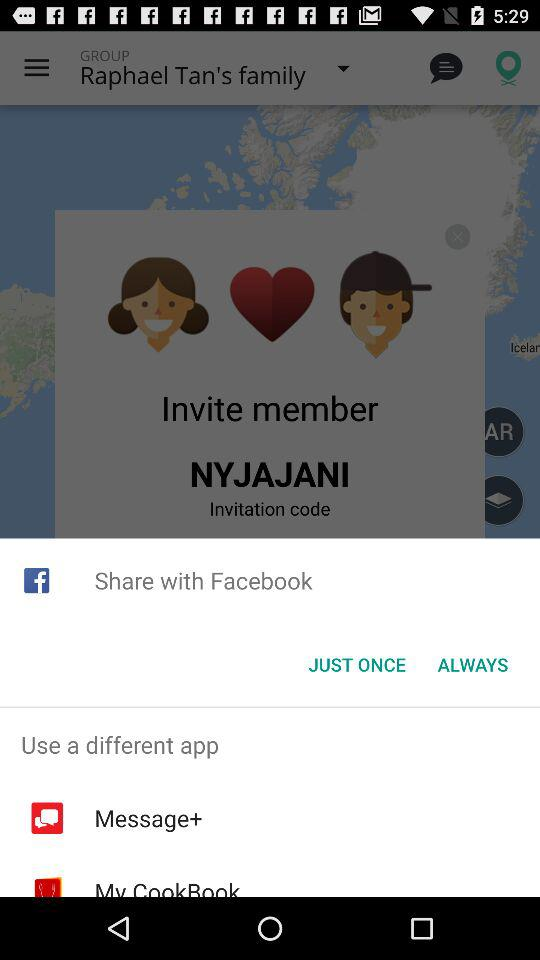What applications can be used to share? You can share it with Facebook. 